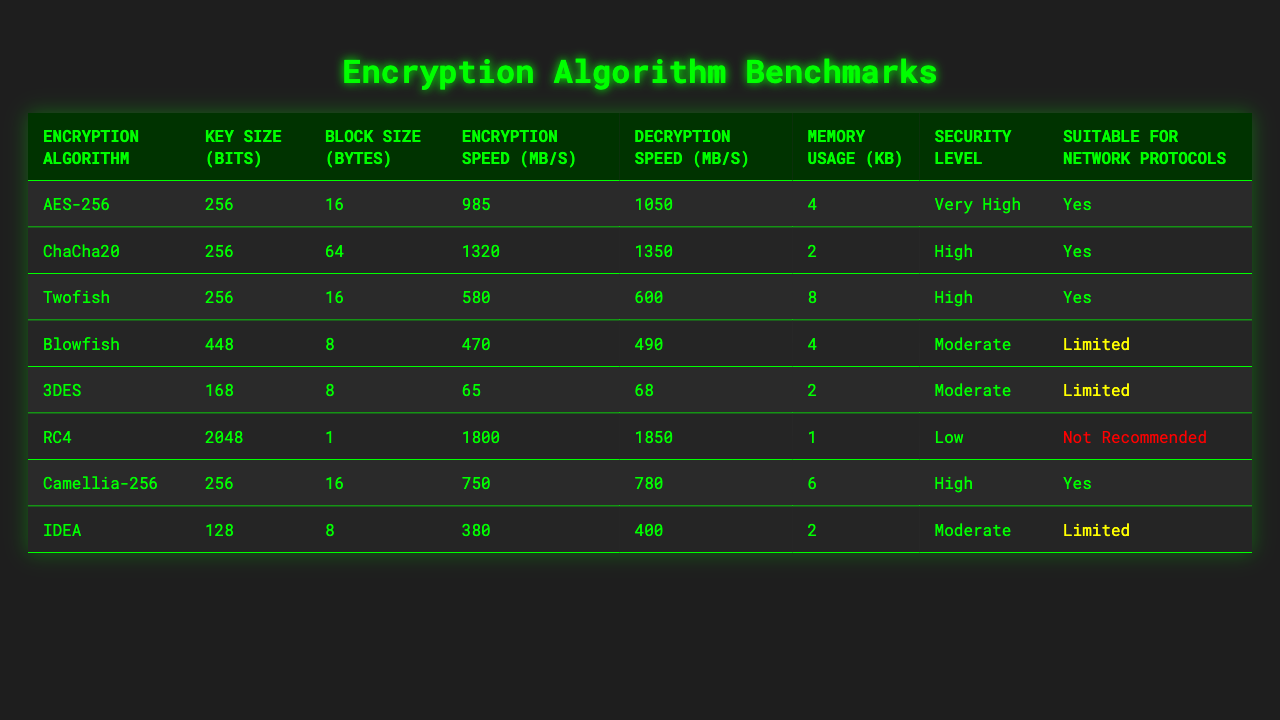What is the encryption speed of AES-256? The table lists the encryption speed for AES-256 as 985 MB/s.
Answer: 985 MB/s Which encryption algorithm has the highest decryption speed? By examining the table, ChaCha20 has the highest decryption speed listed at 1350 MB/s.
Answer: ChaCha20 Is Blowfish suitable for network protocols? The table indicates that Blowfish is labeled as "Limited" for suitability in network protocols.
Answer: No What is the key size of RC4? The key size of RC4 is specified in the table as 2048 bits.
Answer: 2048 bits What is the average memory usage of the algorithms that have a "High" security level? The memory usage for ChaCha20 is 2 KB, for Camellia-256 is 6 KB, and for Twofish is 8 KB. Therefore, the average is (2 + 6 + 8) / 3 = 5.33 KB.
Answer: 5.33 KB Which encryption algorithm has the lowest encryption speed and what is the value? Looking at the encryption speeds, 3DES has the lowest encryption speed at 65 MB/s.
Answer: 3DES, 65 MB/s How many encryption algorithms in the table support network protocols? There are five algorithms listed with "Yes" as the suitability for network protocols: AES-256, ChaCha20, Twofish, Camellia-256.
Answer: 4 algorithms What is the overall decryption speed range for all algorithms? The decryption speeds range from a minimum of 68 MB/s (3DES) to a maximum of 1350 MB/s (ChaCha20).
Answer: 68 to 1350 MB/s Which encryption algorithm uses the least memory? The table shows that RC4 uses the least memory at 1 KB.
Answer: RC4 Is IDEA encryption speed higher than Camellia-256? The encryption speed of IDEA is 380 MB/s, while that of Camellia-256 is 750 MB/s, thus IDEA is not higher.
Answer: No 